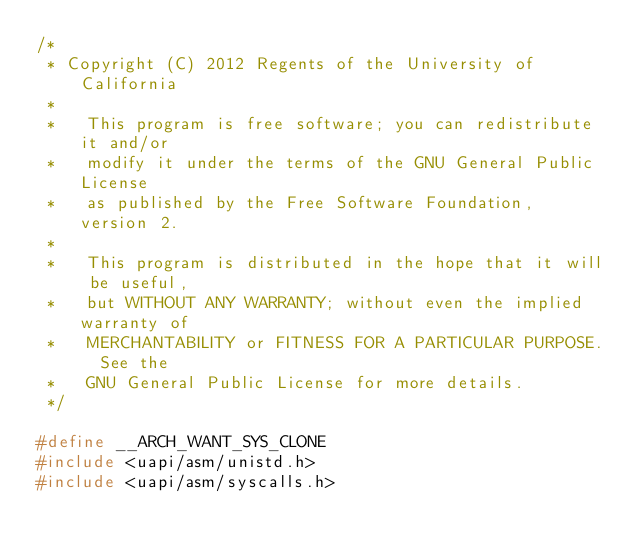<code> <loc_0><loc_0><loc_500><loc_500><_C_>/*
 * Copyright (C) 2012 Regents of the University of California
 *
 *   This program is free software; you can redistribute it and/or
 *   modify it under the terms of the GNU General Public License
 *   as published by the Free Software Foundation, version 2.
 *
 *   This program is distributed in the hope that it will be useful,
 *   but WITHOUT ANY WARRANTY; without even the implied warranty of
 *   MERCHANTABILITY or FITNESS FOR A PARTICULAR PURPOSE.  See the
 *   GNU General Public License for more details.
 */

#define __ARCH_WANT_SYS_CLONE
#include <uapi/asm/unistd.h>
#include <uapi/asm/syscalls.h>
</code> 